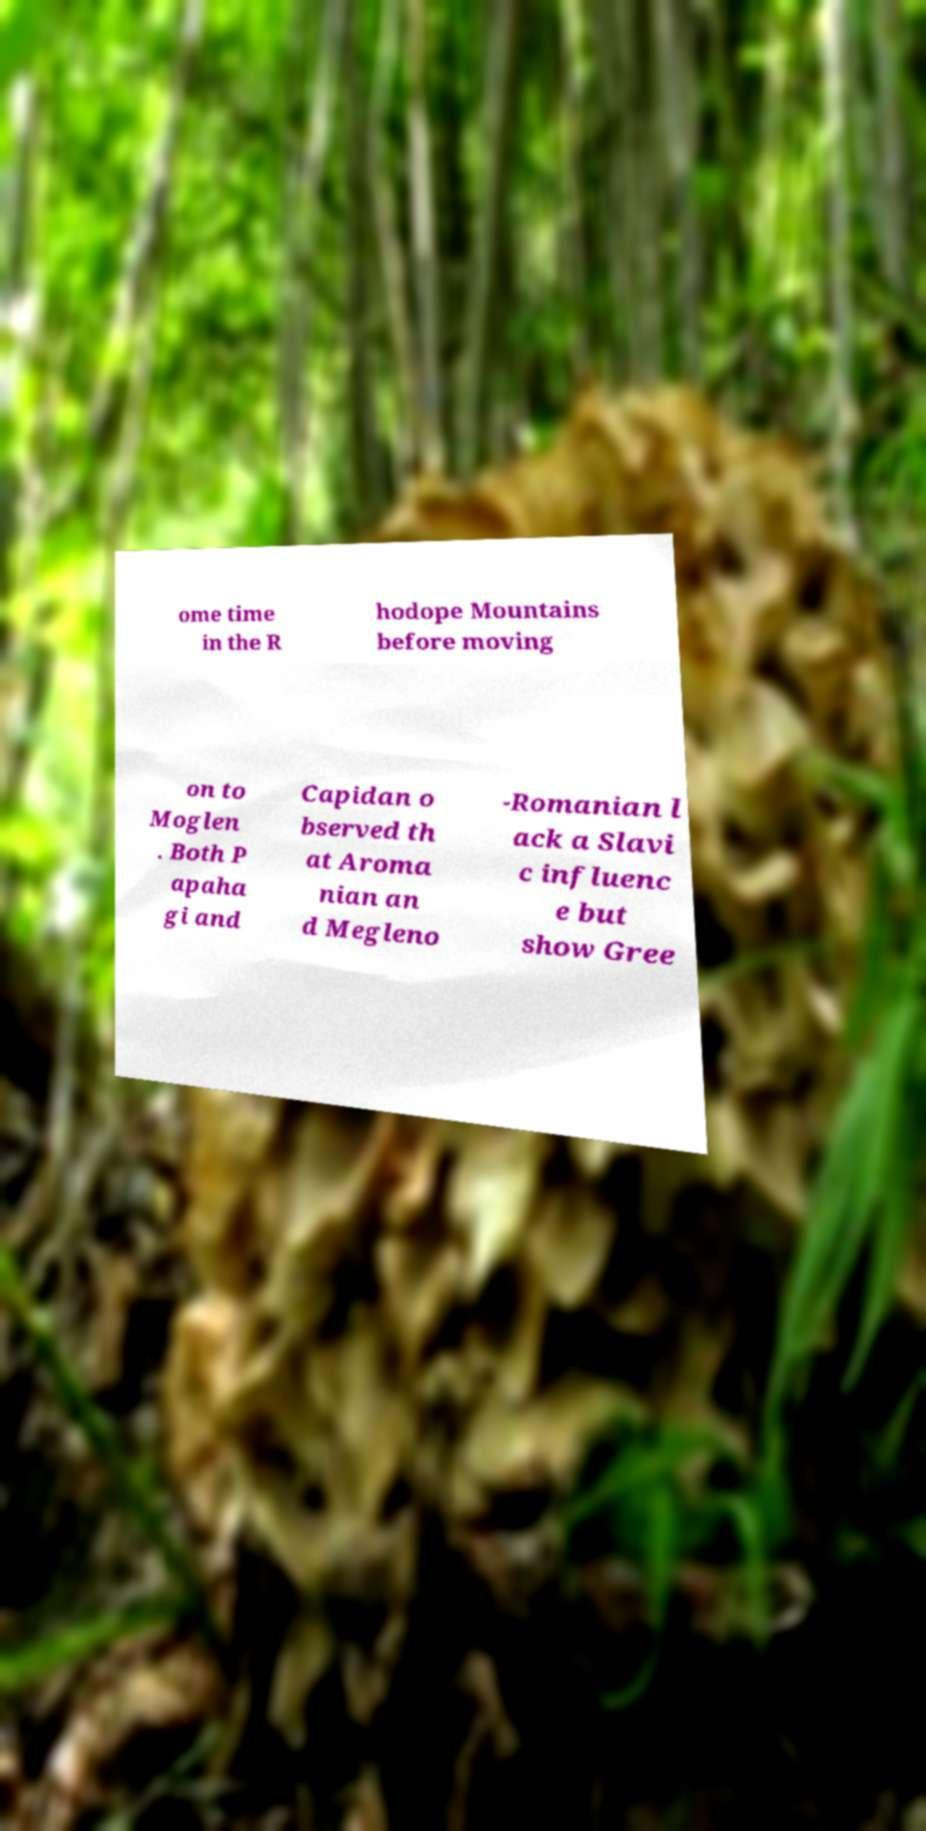For documentation purposes, I need the text within this image transcribed. Could you provide that? ome time in the R hodope Mountains before moving on to Moglen . Both P apaha gi and Capidan o bserved th at Aroma nian an d Megleno -Romanian l ack a Slavi c influenc e but show Gree 